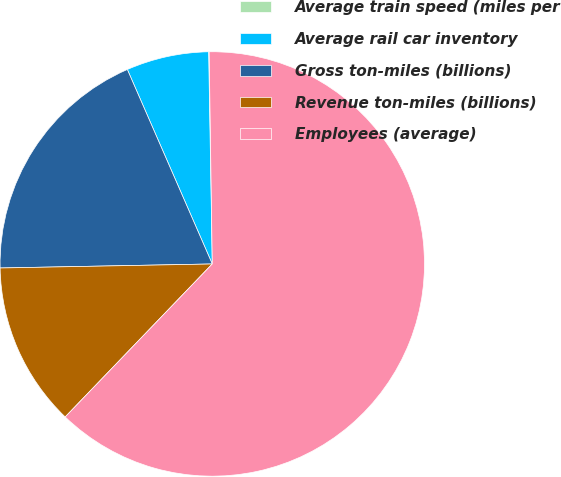<chart> <loc_0><loc_0><loc_500><loc_500><pie_chart><fcel>Average train speed (miles per<fcel>Average rail car inventory<fcel>Gross ton-miles (billions)<fcel>Revenue ton-miles (billions)<fcel>Employees (average)<nl><fcel>0.04%<fcel>6.28%<fcel>18.75%<fcel>12.51%<fcel>62.42%<nl></chart> 